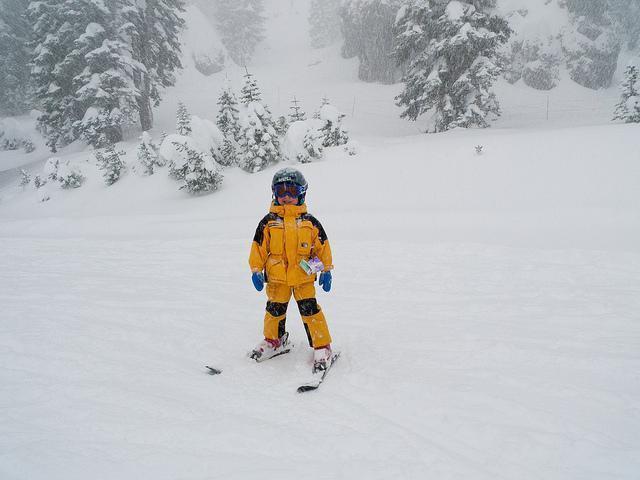How many people in this photo?
Give a very brief answer. 1. How many elephants are there?
Give a very brief answer. 0. 